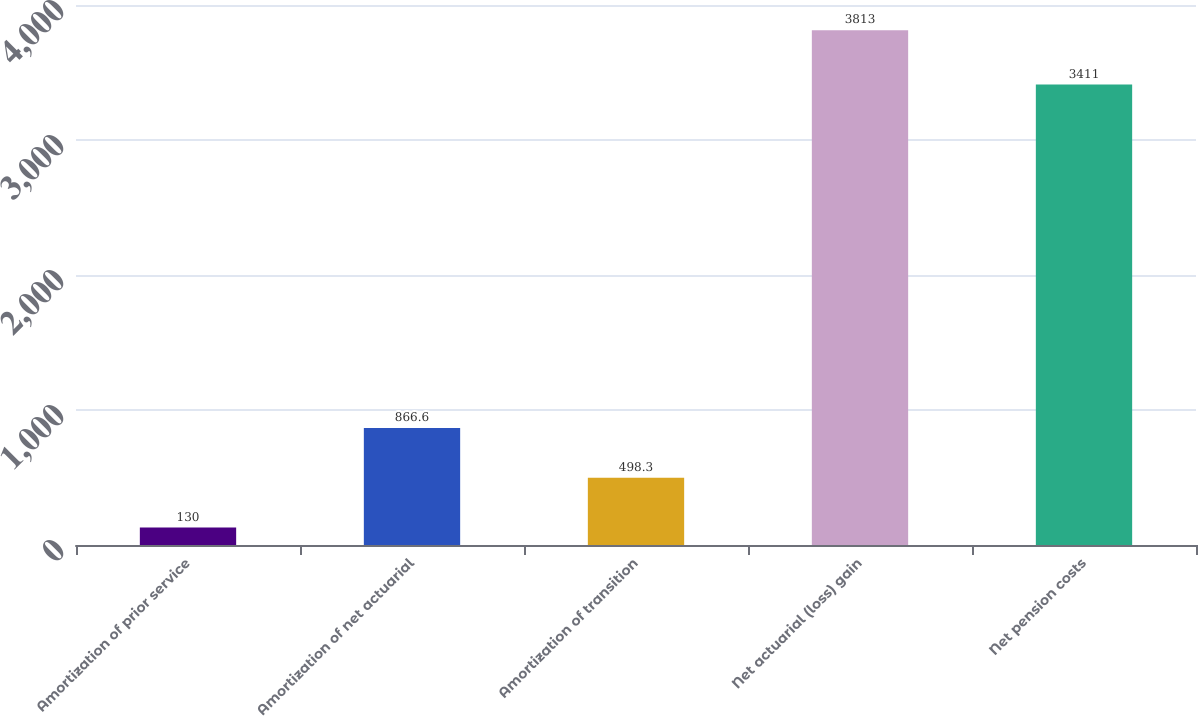<chart> <loc_0><loc_0><loc_500><loc_500><bar_chart><fcel>Amortization of prior service<fcel>Amortization of net actuarial<fcel>Amortization of transition<fcel>Net actuarial (loss) gain<fcel>Net pension costs<nl><fcel>130<fcel>866.6<fcel>498.3<fcel>3813<fcel>3411<nl></chart> 